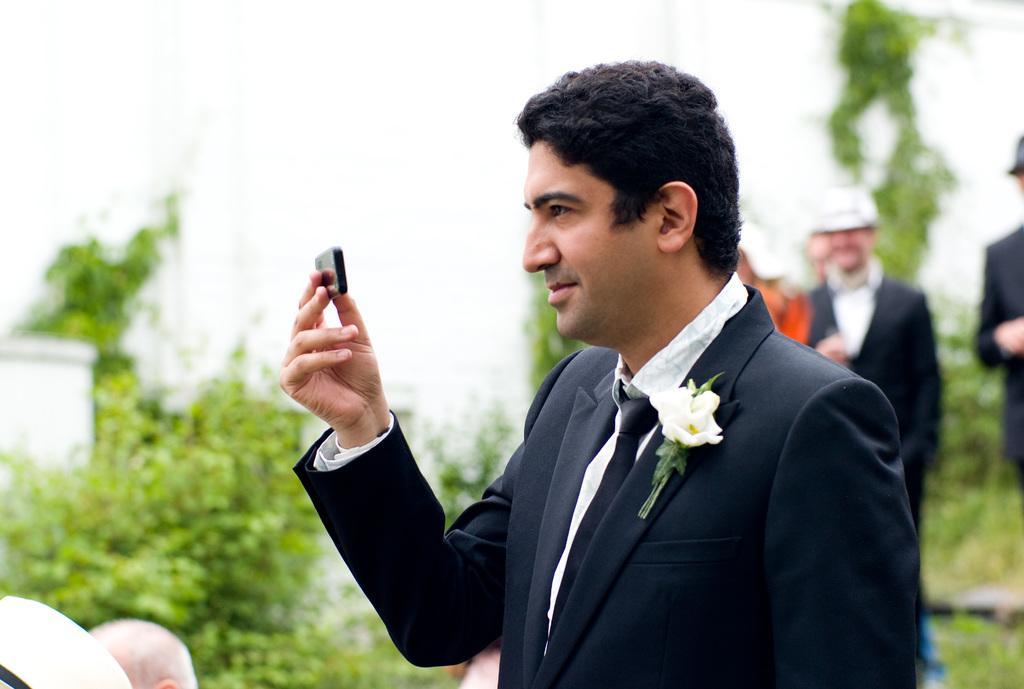How would you summarize this image in a sentence or two? In this picture I can see a man, who is standing in front and I see that he is holding a black color thing in his hand. In the background I see few people and I see the plants. 